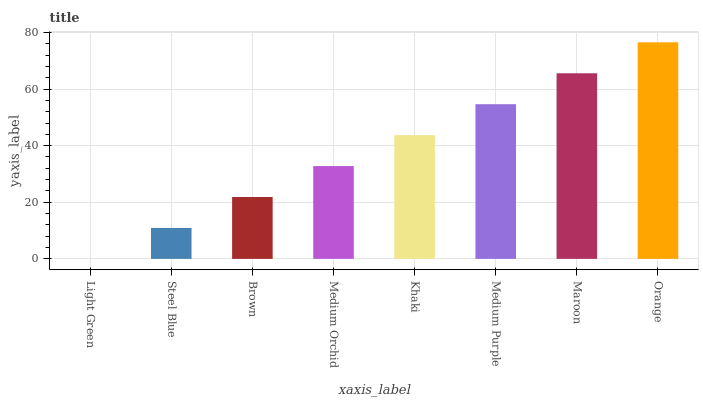Is Steel Blue the minimum?
Answer yes or no. No. Is Steel Blue the maximum?
Answer yes or no. No. Is Steel Blue greater than Light Green?
Answer yes or no. Yes. Is Light Green less than Steel Blue?
Answer yes or no. Yes. Is Light Green greater than Steel Blue?
Answer yes or no. No. Is Steel Blue less than Light Green?
Answer yes or no. No. Is Khaki the high median?
Answer yes or no. Yes. Is Medium Orchid the low median?
Answer yes or no. Yes. Is Steel Blue the high median?
Answer yes or no. No. Is Orange the low median?
Answer yes or no. No. 